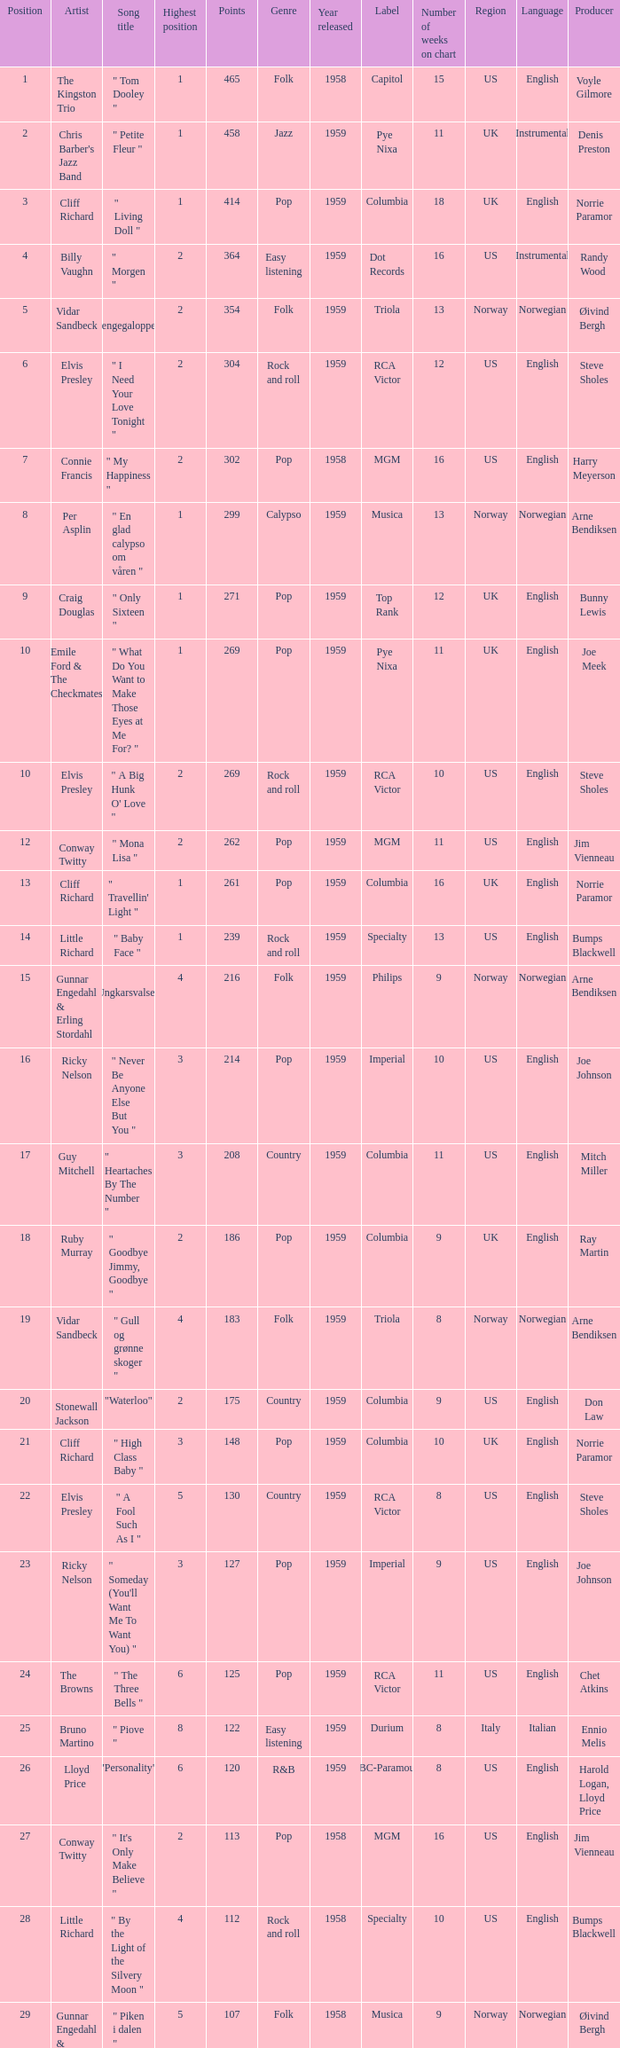What is the nme of the song performed by billy vaughn? " Morgen ". 